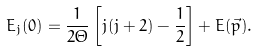Convert formula to latex. <formula><loc_0><loc_0><loc_500><loc_500>E _ { j } ( 0 ) = \frac { 1 } { 2 \Theta } \left [ j ( j + 2 ) - \frac { 1 } { 2 } \right ] + E ( \vec { p } ) .</formula> 